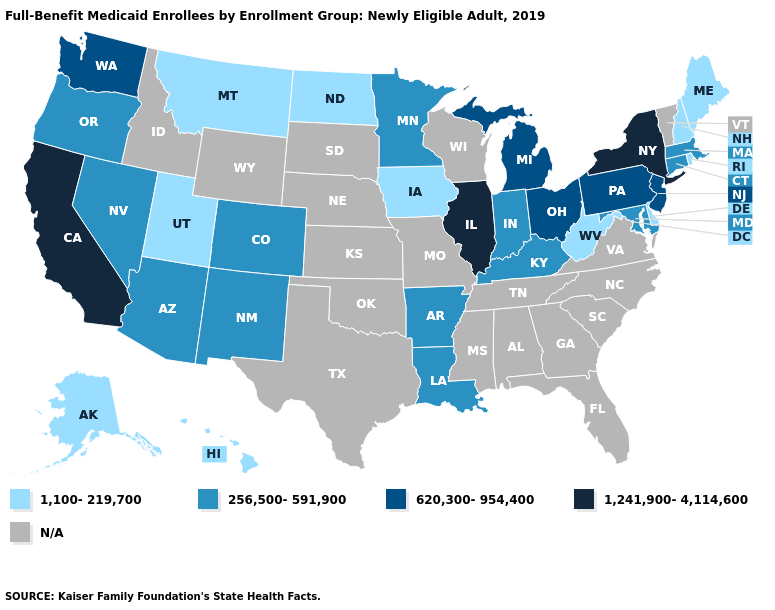Name the states that have a value in the range 256,500-591,900?
Give a very brief answer. Arizona, Arkansas, Colorado, Connecticut, Indiana, Kentucky, Louisiana, Maryland, Massachusetts, Minnesota, Nevada, New Mexico, Oregon. What is the value of Louisiana?
Short answer required. 256,500-591,900. What is the highest value in the USA?
Be succinct. 1,241,900-4,114,600. Does the first symbol in the legend represent the smallest category?
Short answer required. Yes. Which states hav the highest value in the MidWest?
Answer briefly. Illinois. Does Louisiana have the lowest value in the USA?
Short answer required. No. Name the states that have a value in the range 620,300-954,400?
Quick response, please. Michigan, New Jersey, Ohio, Pennsylvania, Washington. How many symbols are there in the legend?
Give a very brief answer. 5. What is the lowest value in the USA?
Give a very brief answer. 1,100-219,700. What is the lowest value in states that border New Hampshire?
Keep it brief. 1,100-219,700. Is the legend a continuous bar?
Keep it brief. No. 